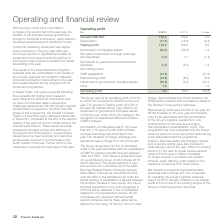From Premier Foods Plc's financial document, What was the operating profit in the year 2018/19 and 2017/18? The document shows two values: £4.5m and £69.3m. From the document: "The Group reports an operating profit of £4.5m for 2018/19, compared to £69.3m in the prior year. The growth in Trading profit of £5.5m in the year op..." Also, What is the adjusted EBITDA in 2018/19? According to the financial document, 145.5 (in millions). The relevant text states: "Adjusted EBITDA 3 145.5 139.6 5.9 Depreciation (17.0) (16.6) (0.4)..." Also, What led to Amortisation of intangibles being £1.9m lower than 2017/18? due to certain SAP software modules becoming fully amortised in the year.. The document states: "sation of intangibles was £1.9m lower than 2017/18 due to certain SAP software modules becoming fully amortised in the year. Fair valuation of foreign..." Also, can you calculate: What is the change in Adjusted EBITDA from 2018/19 to 2017/18? Based on the calculation: 145.5-139.6, the result is 5.9 (in millions). This is based on the information: "Adjusted EBITDA 3 145.5 139.6 5.9 Depreciation (17.0) (16.6) (0.4) Adjusted EBITDA 3 145.5 139.6 5.9 Depreciation (17.0) (16.6) (0.4)..." The key data points involved are: 139.6, 145.5. Also, can you calculate: What is the change in Depreciation from 2018/19 to 2017/18? Based on the calculation: 17.0-16.6, the result is 0.4 (in millions). This is based on the information: "Adjusted EBITDA 3 145.5 139.6 5.9 Depreciation (17.0) (16.6) (0.4) ted EBITDA 3 145.5 139.6 5.9 Depreciation (17.0) (16.6) (0.4)..." The key data points involved are: 16.6, 17.0. Also, can you calculate: What is the change in Trading profit from 2018/19 to 2017/18? Based on the calculation: 128.5-123.0, the result is 5.5 (in millions). This is based on the information: "Trading profit 128.5 123.0 5.5 Amortisation of intangible assets (34.4) (36.3) 1.9 Fair value movements on foreign excha Trading profit 128.5 123.0 5.5 Amortisation of intangible assets (34.4) (36.3) ..." The key data points involved are: 123.0, 128.5. 